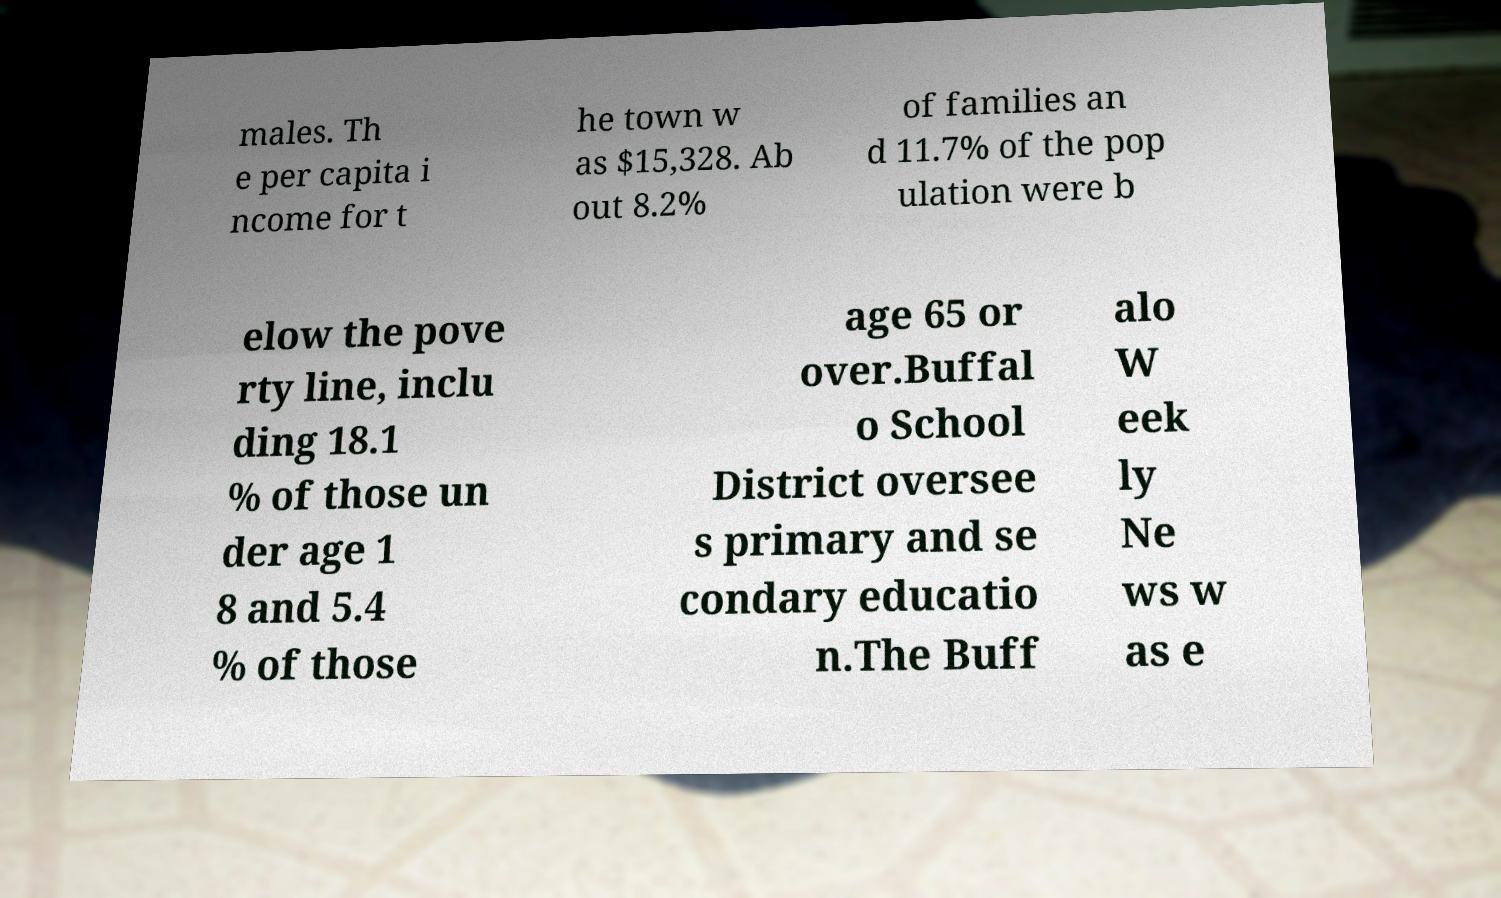For documentation purposes, I need the text within this image transcribed. Could you provide that? males. Th e per capita i ncome for t he town w as $15,328. Ab out 8.2% of families an d 11.7% of the pop ulation were b elow the pove rty line, inclu ding 18.1 % of those un der age 1 8 and 5.4 % of those age 65 or over.Buffal o School District oversee s primary and se condary educatio n.The Buff alo W eek ly Ne ws w as e 